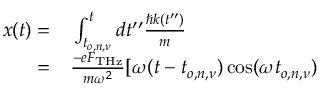Convert formula to latex. <formula><loc_0><loc_0><loc_500><loc_500>\begin{array} { r l } { x ( t ) = } & \int _ { t _ { o , n , \nu } } ^ { t } d t ^ { \prime \prime } \frac { \hbar { k } ( t ^ { \prime \prime } ) } { m } } \\ { = } & \frac { - e F _ { T H z } } { m \omega ^ { 2 } } [ \omega ( t - t _ { o , n , \nu } ) \cos ( \omega t _ { o , n , \nu } ) } \end{array}</formula> 